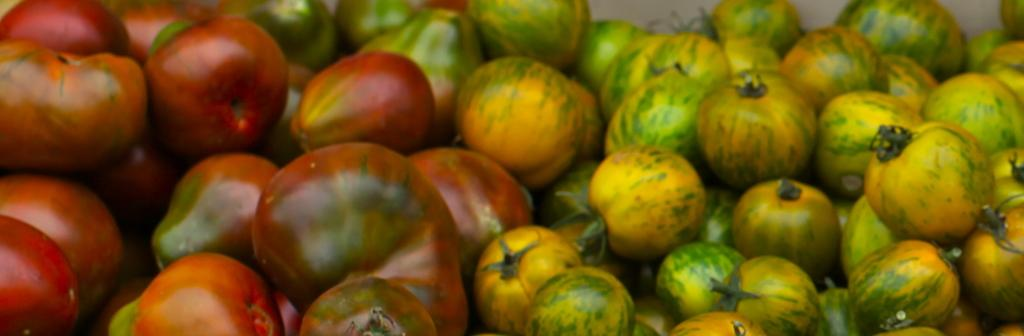What is the main subject of the image? The main subject of the image is tomatoes. How many colors are the tomatoes in the image? The tomatoes are in green, yellow, and red colors. What type of rice is being served in the mouth of the person in the image? There is no person or rice present in the image; it only features tomatoes in green, yellow, and red colors. 